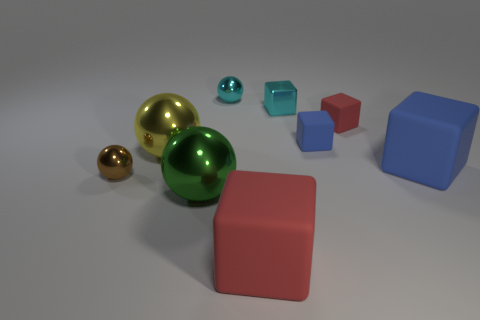Subtract all cyan cubes. How many cubes are left? 4 Subtract 5 blocks. How many blocks are left? 0 Add 1 tiny blue rubber blocks. How many objects exist? 10 Subtract all cyan blocks. How many blocks are left? 4 Add 3 large things. How many large things exist? 7 Subtract 0 purple cylinders. How many objects are left? 9 Subtract all blocks. How many objects are left? 4 Subtract all purple balls. Subtract all green blocks. How many balls are left? 4 Subtract all green spheres. How many yellow blocks are left? 0 Subtract all small matte cylinders. Subtract all cyan metal cubes. How many objects are left? 8 